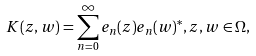Convert formula to latex. <formula><loc_0><loc_0><loc_500><loc_500>K ( z , w ) = \sum _ { n = 0 } ^ { \infty } e _ { n } ( z ) e _ { n } ( w ) ^ { * } , z , w \in \Omega ,</formula> 